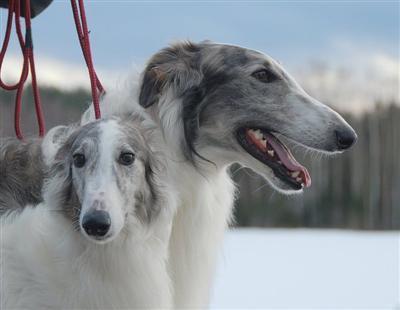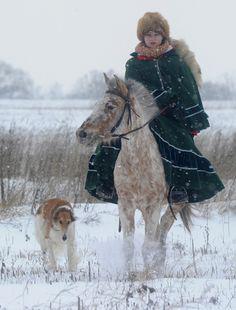The first image is the image on the left, the second image is the image on the right. Considering the images on both sides, is "There are three dogs and a woman" valid? Answer yes or no. Yes. The first image is the image on the left, the second image is the image on the right. For the images shown, is this caption "One image is a wintry scene featuring a woman bundled up in a flowing garment with at least one hound on the left." true? Answer yes or no. Yes. 